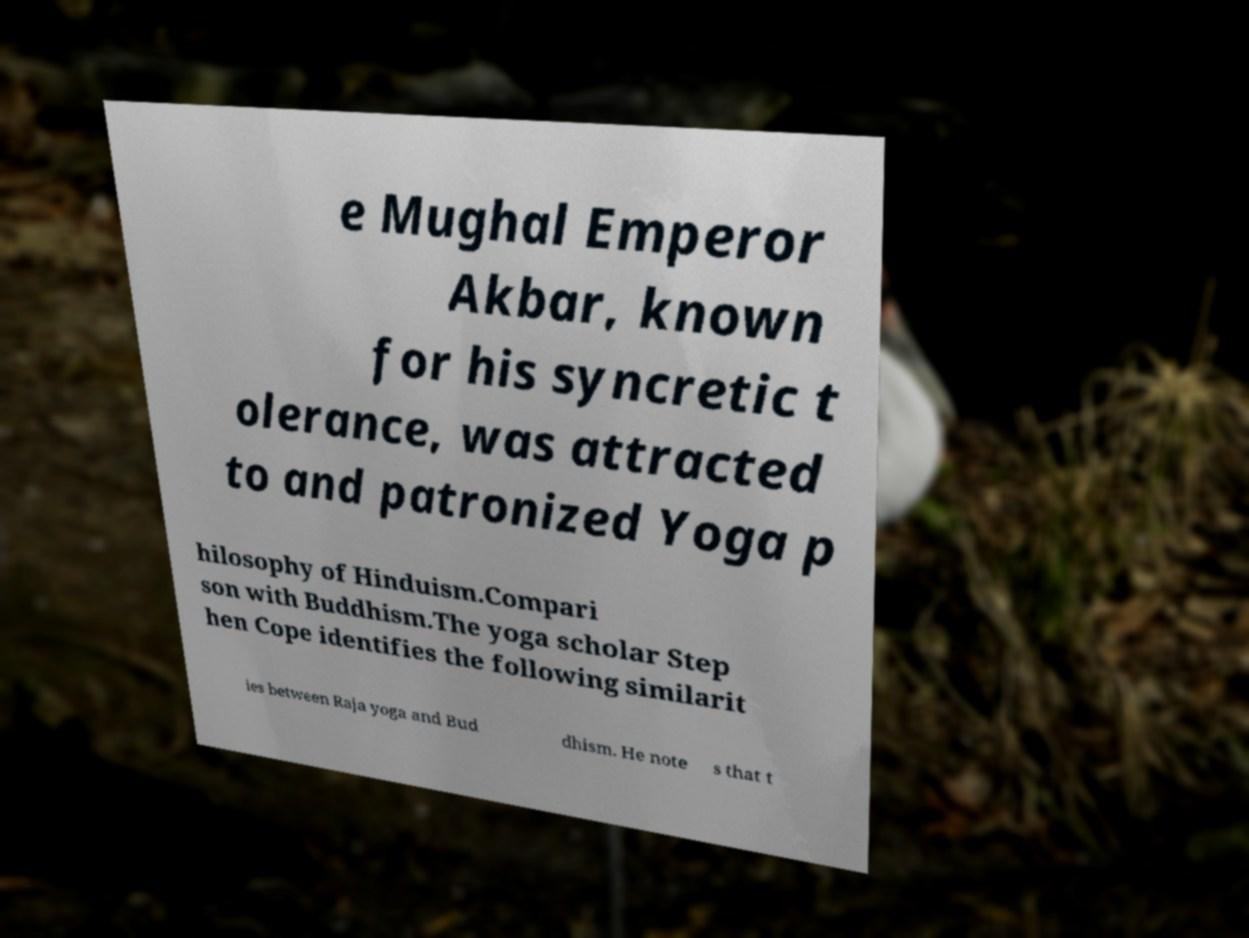Could you assist in decoding the text presented in this image and type it out clearly? e Mughal Emperor Akbar, known for his syncretic t olerance, was attracted to and patronized Yoga p hilosophy of Hinduism.Compari son with Buddhism.The yoga scholar Step hen Cope identifies the following similarit ies between Raja yoga and Bud dhism. He note s that t 